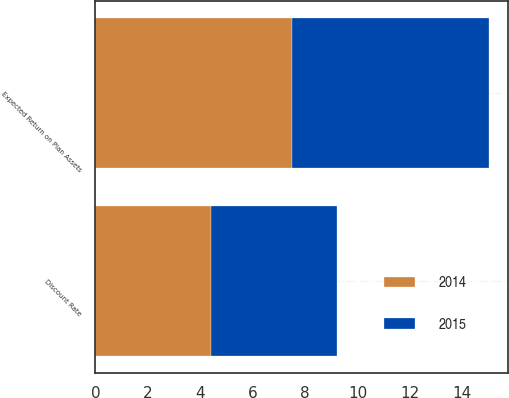Convert chart to OTSL. <chart><loc_0><loc_0><loc_500><loc_500><stacked_bar_chart><ecel><fcel>Discount Rate<fcel>Expected Return on Plan Assets<nl><fcel>2015<fcel>4.8<fcel>7.5<nl><fcel>2014<fcel>4.4<fcel>7.5<nl></chart> 